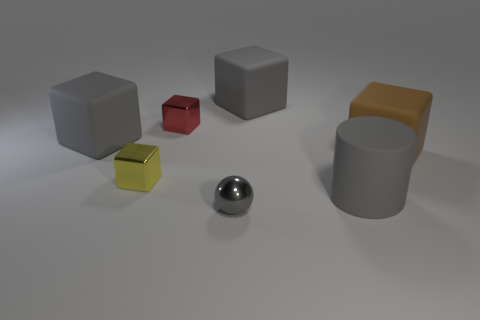There is a cylinder that is the same color as the sphere; what is its size?
Your response must be concise. Large. There is a small yellow metal object; is its shape the same as the large rubber thing right of the large cylinder?
Your answer should be compact. Yes. What is the color of the matte cylinder that is the same size as the brown rubber block?
Your answer should be compact. Gray. Is the number of big things that are behind the large gray matte cylinder less than the number of tiny yellow objects that are behind the red shiny block?
Your response must be concise. No. What is the shape of the gray matte object to the left of the tiny thing that is in front of the large gray object in front of the large brown matte object?
Your response must be concise. Cube. There is a small object in front of the yellow object; is it the same color as the matte thing that is to the left of the gray metallic object?
Give a very brief answer. Yes. The metallic thing that is the same color as the big matte cylinder is what shape?
Provide a succinct answer. Sphere. What number of metal objects are tiny blocks or small balls?
Give a very brief answer. 3. What color is the small block that is in front of the brown rubber cube on the right side of the cube in front of the brown matte thing?
Keep it short and to the point. Yellow. What color is the other small metallic thing that is the same shape as the tiny yellow metal thing?
Your answer should be very brief. Red. 